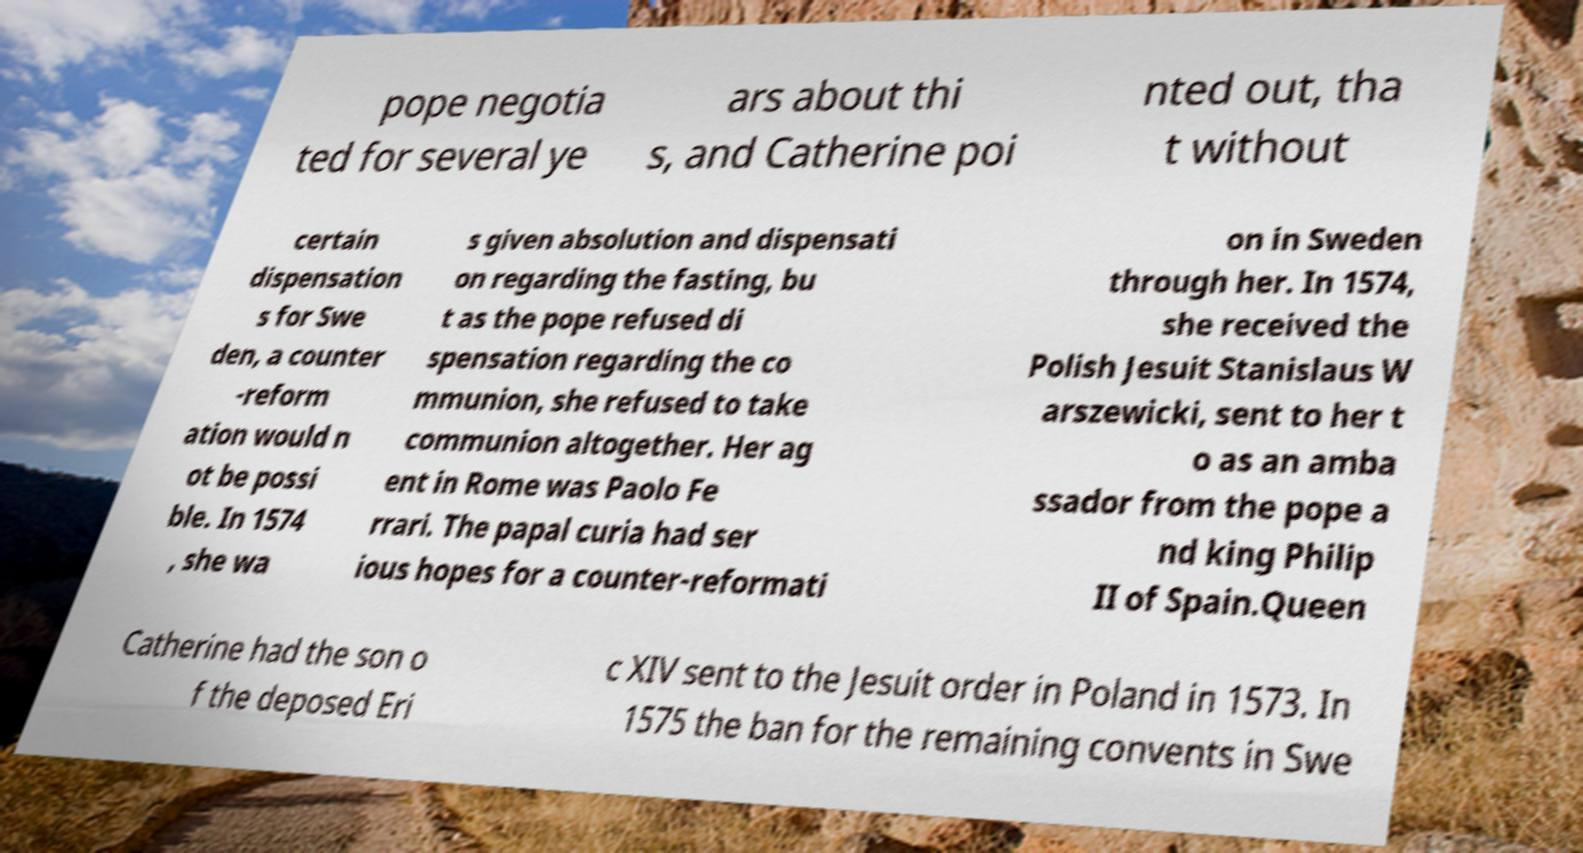I need the written content from this picture converted into text. Can you do that? pope negotia ted for several ye ars about thi s, and Catherine poi nted out, tha t without certain dispensation s for Swe den, a counter -reform ation would n ot be possi ble. In 1574 , she wa s given absolution and dispensati on regarding the fasting, bu t as the pope refused di spensation regarding the co mmunion, she refused to take communion altogether. Her ag ent in Rome was Paolo Fe rrari. The papal curia had ser ious hopes for a counter-reformati on in Sweden through her. In 1574, she received the Polish Jesuit Stanislaus W arszewicki, sent to her t o as an amba ssador from the pope a nd king Philip II of Spain.Queen Catherine had the son o f the deposed Eri c XIV sent to the Jesuit order in Poland in 1573. In 1575 the ban for the remaining convents in Swe 